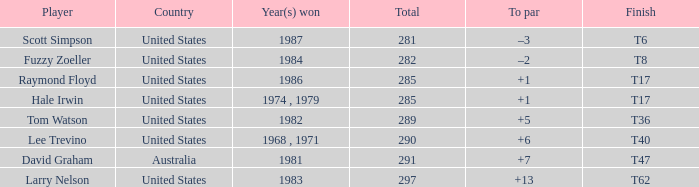In which year did hale irwin secure a win with 285 points? 1974 , 1979. 